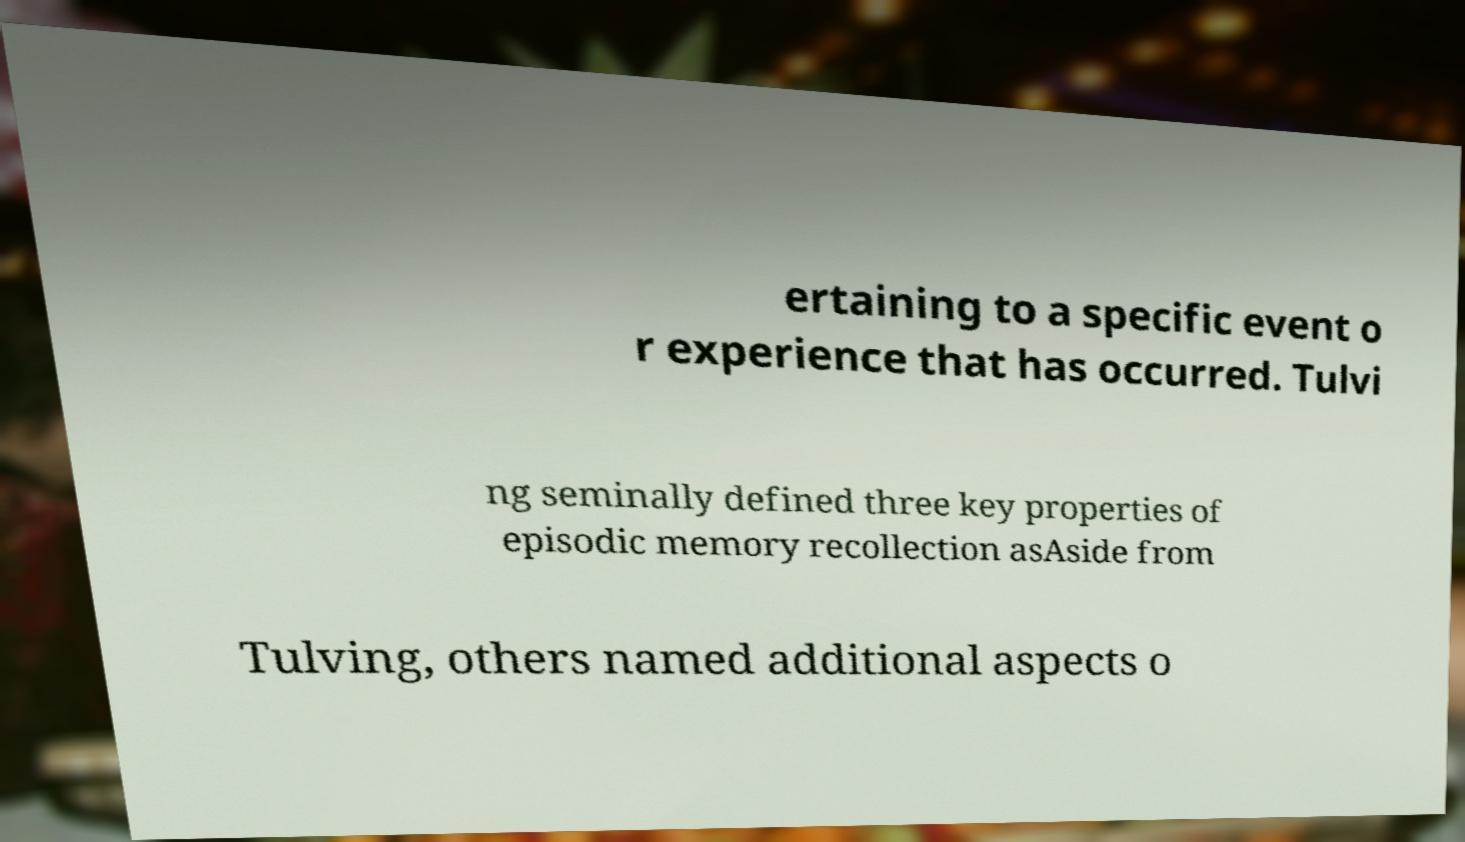I need the written content from this picture converted into text. Can you do that? ertaining to a specific event o r experience that has occurred. Tulvi ng seminally defined three key properties of episodic memory recollection asAside from Tulving, others named additional aspects o 